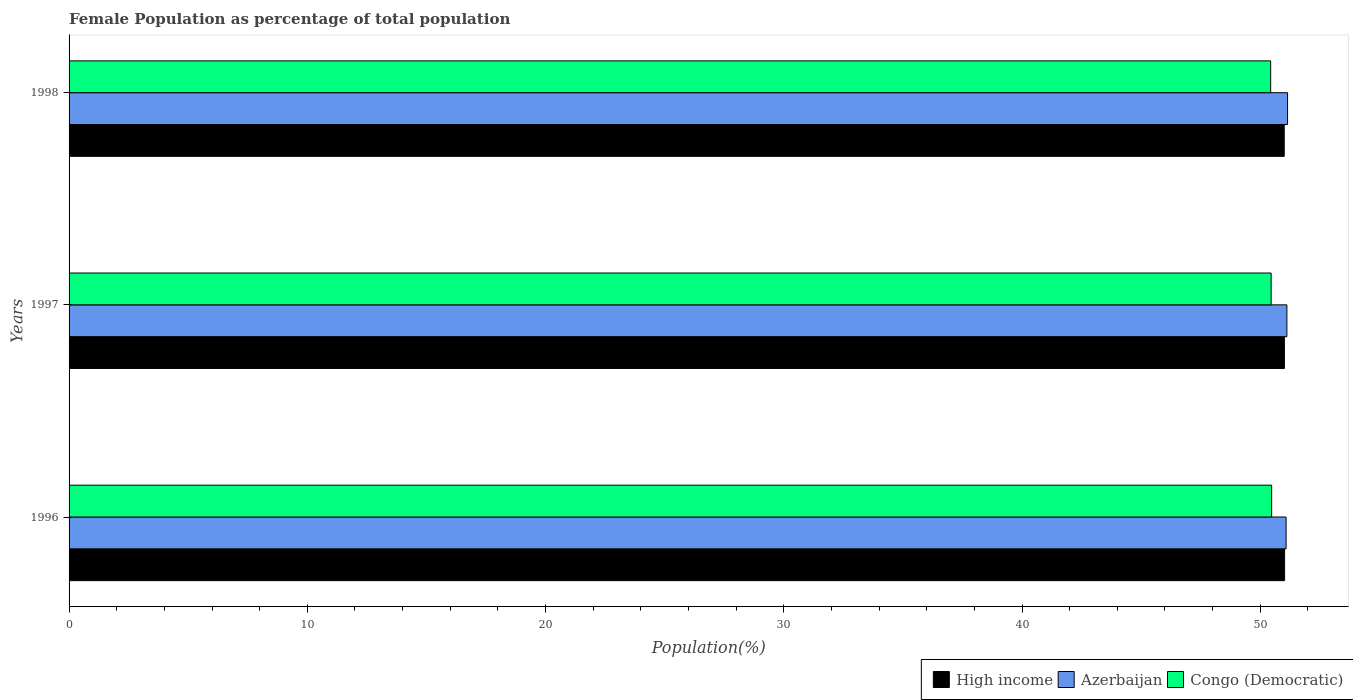Are the number of bars on each tick of the Y-axis equal?
Provide a short and direct response. Yes. How many bars are there on the 1st tick from the top?
Make the answer very short. 3. How many bars are there on the 2nd tick from the bottom?
Provide a short and direct response. 3. What is the female population in in Congo (Democratic) in 1996?
Keep it short and to the point. 50.48. Across all years, what is the maximum female population in in Azerbaijan?
Ensure brevity in your answer.  51.15. Across all years, what is the minimum female population in in Congo (Democratic)?
Keep it short and to the point. 50.44. What is the total female population in in High income in the graph?
Give a very brief answer. 153.04. What is the difference between the female population in in Azerbaijan in 1996 and that in 1997?
Keep it short and to the point. -0.03. What is the difference between the female population in in Congo (Democratic) in 1998 and the female population in in Azerbaijan in 1997?
Your response must be concise. -0.68. What is the average female population in in High income per year?
Make the answer very short. 51.01. In the year 1998, what is the difference between the female population in in Congo (Democratic) and female population in in Azerbaijan?
Keep it short and to the point. -0.71. In how many years, is the female population in in High income greater than 30 %?
Offer a terse response. 3. What is the ratio of the female population in in Azerbaijan in 1997 to that in 1998?
Provide a succinct answer. 1. What is the difference between the highest and the second highest female population in in Azerbaijan?
Your answer should be very brief. 0.03. What is the difference between the highest and the lowest female population in in Congo (Democratic)?
Give a very brief answer. 0.04. In how many years, is the female population in in High income greater than the average female population in in High income taken over all years?
Provide a short and direct response. 1. Is the sum of the female population in in High income in 1997 and 1998 greater than the maximum female population in in Congo (Democratic) across all years?
Your answer should be very brief. Yes. Are all the bars in the graph horizontal?
Your answer should be compact. Yes. How many years are there in the graph?
Keep it short and to the point. 3. What is the difference between two consecutive major ticks on the X-axis?
Provide a succinct answer. 10. Are the values on the major ticks of X-axis written in scientific E-notation?
Your answer should be very brief. No. Does the graph contain grids?
Your response must be concise. No. Where does the legend appear in the graph?
Provide a succinct answer. Bottom right. How are the legend labels stacked?
Provide a succinct answer. Horizontal. What is the title of the graph?
Provide a short and direct response. Female Population as percentage of total population. Does "Azerbaijan" appear as one of the legend labels in the graph?
Ensure brevity in your answer.  Yes. What is the label or title of the X-axis?
Offer a very short reply. Population(%). What is the label or title of the Y-axis?
Give a very brief answer. Years. What is the Population(%) in High income in 1996?
Your answer should be very brief. 51.02. What is the Population(%) in Azerbaijan in 1996?
Offer a very short reply. 51.08. What is the Population(%) of Congo (Democratic) in 1996?
Your response must be concise. 50.48. What is the Population(%) of High income in 1997?
Keep it short and to the point. 51.01. What is the Population(%) in Azerbaijan in 1997?
Keep it short and to the point. 51.12. What is the Population(%) of Congo (Democratic) in 1997?
Provide a short and direct response. 50.46. What is the Population(%) in High income in 1998?
Give a very brief answer. 51.01. What is the Population(%) of Azerbaijan in 1998?
Your answer should be compact. 51.15. What is the Population(%) in Congo (Democratic) in 1998?
Provide a succinct answer. 50.44. Across all years, what is the maximum Population(%) of High income?
Make the answer very short. 51.02. Across all years, what is the maximum Population(%) in Azerbaijan?
Give a very brief answer. 51.15. Across all years, what is the maximum Population(%) in Congo (Democratic)?
Offer a terse response. 50.48. Across all years, what is the minimum Population(%) in High income?
Your answer should be very brief. 51.01. Across all years, what is the minimum Population(%) of Azerbaijan?
Offer a very short reply. 51.08. Across all years, what is the minimum Population(%) in Congo (Democratic)?
Ensure brevity in your answer.  50.44. What is the total Population(%) in High income in the graph?
Your answer should be very brief. 153.04. What is the total Population(%) in Azerbaijan in the graph?
Ensure brevity in your answer.  153.35. What is the total Population(%) of Congo (Democratic) in the graph?
Offer a terse response. 151.38. What is the difference between the Population(%) of High income in 1996 and that in 1997?
Offer a terse response. 0.01. What is the difference between the Population(%) of Azerbaijan in 1996 and that in 1997?
Provide a short and direct response. -0.03. What is the difference between the Population(%) in Congo (Democratic) in 1996 and that in 1997?
Make the answer very short. 0.02. What is the difference between the Population(%) of High income in 1996 and that in 1998?
Ensure brevity in your answer.  0.01. What is the difference between the Population(%) of Azerbaijan in 1996 and that in 1998?
Provide a short and direct response. -0.06. What is the difference between the Population(%) in Congo (Democratic) in 1996 and that in 1998?
Keep it short and to the point. 0.04. What is the difference between the Population(%) in High income in 1997 and that in 1998?
Provide a succinct answer. 0.01. What is the difference between the Population(%) in Azerbaijan in 1997 and that in 1998?
Provide a succinct answer. -0.03. What is the difference between the Population(%) of Congo (Democratic) in 1997 and that in 1998?
Keep it short and to the point. 0.02. What is the difference between the Population(%) in High income in 1996 and the Population(%) in Azerbaijan in 1997?
Your answer should be compact. -0.1. What is the difference between the Population(%) in High income in 1996 and the Population(%) in Congo (Democratic) in 1997?
Your answer should be very brief. 0.56. What is the difference between the Population(%) in Azerbaijan in 1996 and the Population(%) in Congo (Democratic) in 1997?
Provide a short and direct response. 0.63. What is the difference between the Population(%) in High income in 1996 and the Population(%) in Azerbaijan in 1998?
Your answer should be very brief. -0.13. What is the difference between the Population(%) in High income in 1996 and the Population(%) in Congo (Democratic) in 1998?
Ensure brevity in your answer.  0.58. What is the difference between the Population(%) in Azerbaijan in 1996 and the Population(%) in Congo (Democratic) in 1998?
Make the answer very short. 0.65. What is the difference between the Population(%) of High income in 1997 and the Population(%) of Azerbaijan in 1998?
Offer a terse response. -0.13. What is the difference between the Population(%) of High income in 1997 and the Population(%) of Congo (Democratic) in 1998?
Offer a terse response. 0.58. What is the difference between the Population(%) of Azerbaijan in 1997 and the Population(%) of Congo (Democratic) in 1998?
Your answer should be very brief. 0.68. What is the average Population(%) of High income per year?
Keep it short and to the point. 51.01. What is the average Population(%) in Azerbaijan per year?
Ensure brevity in your answer.  51.12. What is the average Population(%) of Congo (Democratic) per year?
Provide a short and direct response. 50.46. In the year 1996, what is the difference between the Population(%) of High income and Population(%) of Azerbaijan?
Offer a very short reply. -0.06. In the year 1996, what is the difference between the Population(%) of High income and Population(%) of Congo (Democratic)?
Your response must be concise. 0.54. In the year 1996, what is the difference between the Population(%) of Azerbaijan and Population(%) of Congo (Democratic)?
Your response must be concise. 0.6. In the year 1997, what is the difference between the Population(%) of High income and Population(%) of Azerbaijan?
Give a very brief answer. -0.11. In the year 1997, what is the difference between the Population(%) of High income and Population(%) of Congo (Democratic)?
Provide a short and direct response. 0.56. In the year 1997, what is the difference between the Population(%) of Azerbaijan and Population(%) of Congo (Democratic)?
Offer a very short reply. 0.66. In the year 1998, what is the difference between the Population(%) in High income and Population(%) in Azerbaijan?
Your response must be concise. -0.14. In the year 1998, what is the difference between the Population(%) of High income and Population(%) of Congo (Democratic)?
Keep it short and to the point. 0.57. In the year 1998, what is the difference between the Population(%) of Azerbaijan and Population(%) of Congo (Democratic)?
Your answer should be very brief. 0.71. What is the ratio of the Population(%) of Azerbaijan in 1996 to that in 1997?
Provide a short and direct response. 1. What is the ratio of the Population(%) in Congo (Democratic) in 1996 to that in 1997?
Offer a very short reply. 1. What is the ratio of the Population(%) in High income in 1996 to that in 1998?
Your answer should be compact. 1. What is the ratio of the Population(%) in Azerbaijan in 1996 to that in 1998?
Give a very brief answer. 1. What is the ratio of the Population(%) in Congo (Democratic) in 1996 to that in 1998?
Make the answer very short. 1. What is the ratio of the Population(%) in High income in 1997 to that in 1998?
Offer a very short reply. 1. What is the ratio of the Population(%) in Azerbaijan in 1997 to that in 1998?
Your answer should be compact. 1. What is the ratio of the Population(%) of Congo (Democratic) in 1997 to that in 1998?
Keep it short and to the point. 1. What is the difference between the highest and the second highest Population(%) of High income?
Your answer should be compact. 0.01. What is the difference between the highest and the second highest Population(%) of Azerbaijan?
Your answer should be very brief. 0.03. What is the difference between the highest and the second highest Population(%) in Congo (Democratic)?
Keep it short and to the point. 0.02. What is the difference between the highest and the lowest Population(%) in High income?
Your response must be concise. 0.01. What is the difference between the highest and the lowest Population(%) in Azerbaijan?
Give a very brief answer. 0.06. What is the difference between the highest and the lowest Population(%) of Congo (Democratic)?
Provide a succinct answer. 0.04. 